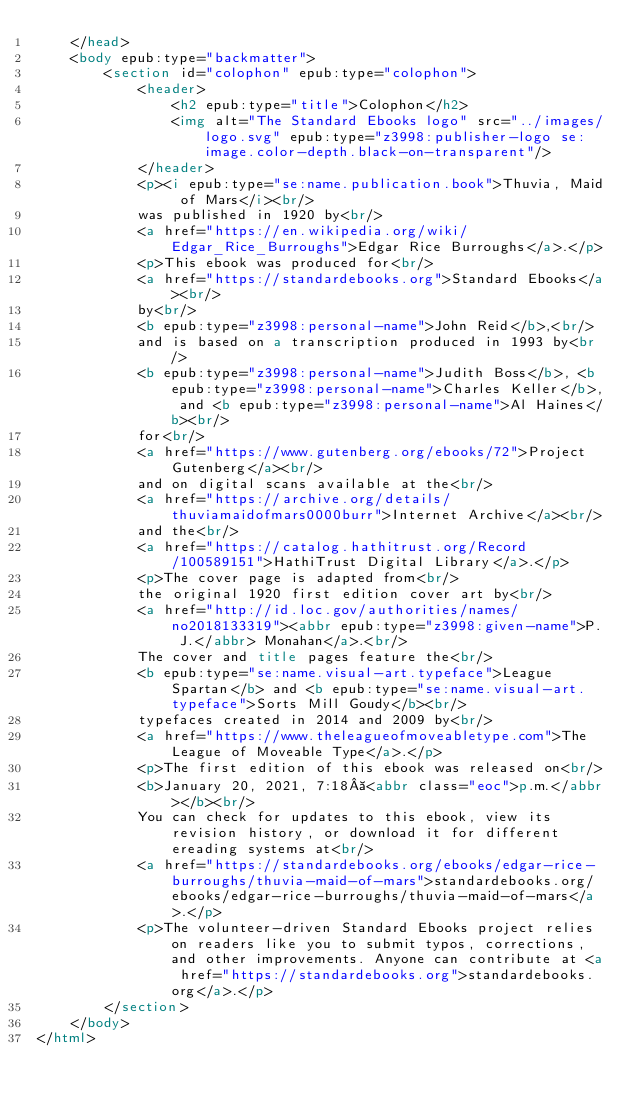Convert code to text. <code><loc_0><loc_0><loc_500><loc_500><_HTML_>	</head>
	<body epub:type="backmatter">
		<section id="colophon" epub:type="colophon">
			<header>
				<h2 epub:type="title">Colophon</h2>
				<img alt="The Standard Ebooks logo" src="../images/logo.svg" epub:type="z3998:publisher-logo se:image.color-depth.black-on-transparent"/>
			</header>
			<p><i epub:type="se:name.publication.book">Thuvia, Maid of Mars</i><br/>
			was published in 1920 by<br/>
			<a href="https://en.wikipedia.org/wiki/Edgar_Rice_Burroughs">Edgar Rice Burroughs</a>.</p>
			<p>This ebook was produced for<br/>
			<a href="https://standardebooks.org">Standard Ebooks</a><br/>
			by<br/>
			<b epub:type="z3998:personal-name">John Reid</b>,<br/>
			and is based on a transcription produced in 1993 by<br/>
			<b epub:type="z3998:personal-name">Judith Boss</b>, <b epub:type="z3998:personal-name">Charles Keller</b>, and <b epub:type="z3998:personal-name">Al Haines</b><br/>
			for<br/>
			<a href="https://www.gutenberg.org/ebooks/72">Project Gutenberg</a><br/>
			and on digital scans available at the<br/>
			<a href="https://archive.org/details/thuviamaidofmars0000burr">Internet Archive</a><br/>
			and the<br/>
			<a href="https://catalog.hathitrust.org/Record/100589151">HathiTrust Digital Library</a>.</p>
			<p>The cover page is adapted from<br/>
			the original 1920 first edition cover art by<br/>
			<a href="http://id.loc.gov/authorities/names/no2018133319"><abbr epub:type="z3998:given-name">P. J.</abbr> Monahan</a>.<br/>
			The cover and title pages feature the<br/>
			<b epub:type="se:name.visual-art.typeface">League Spartan</b> and <b epub:type="se:name.visual-art.typeface">Sorts Mill Goudy</b><br/>
			typefaces created in 2014 and 2009 by<br/>
			<a href="https://www.theleagueofmoveabletype.com">The League of Moveable Type</a>.</p>
			<p>The first edition of this ebook was released on<br/>
			<b>January 20, 2021, 7:18 <abbr class="eoc">p.m.</abbr></b><br/>
			You can check for updates to this ebook, view its revision history, or download it for different ereading systems at<br/>
			<a href="https://standardebooks.org/ebooks/edgar-rice-burroughs/thuvia-maid-of-mars">standardebooks.org/ebooks/edgar-rice-burroughs/thuvia-maid-of-mars</a>.</p>
			<p>The volunteer-driven Standard Ebooks project relies on readers like you to submit typos, corrections, and other improvements. Anyone can contribute at <a href="https://standardebooks.org">standardebooks.org</a>.</p>
		</section>
	</body>
</html>
</code> 